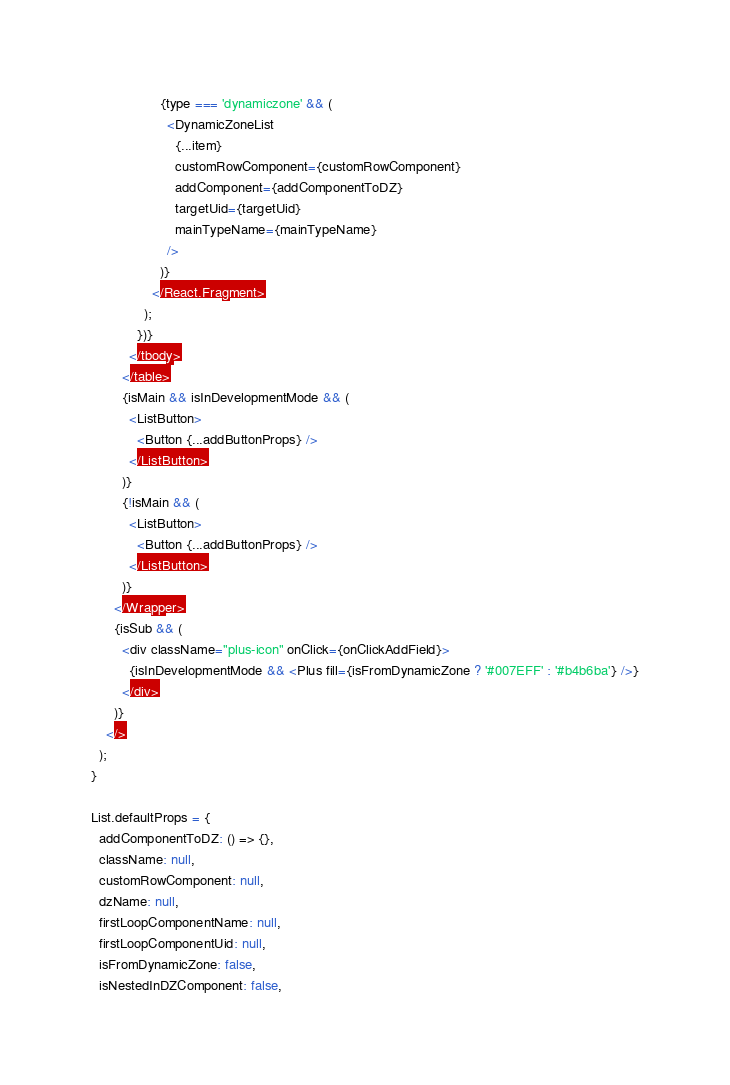<code> <loc_0><loc_0><loc_500><loc_500><_JavaScript_>
                  {type === 'dynamiczone' && (
                    <DynamicZoneList
                      {...item}
                      customRowComponent={customRowComponent}
                      addComponent={addComponentToDZ}
                      targetUid={targetUid}
                      mainTypeName={mainTypeName}
                    />
                  )}
                </React.Fragment>
              );
            })}
          </tbody>
        </table>
        {isMain && isInDevelopmentMode && (
          <ListButton>
            <Button {...addButtonProps} />
          </ListButton>
        )}
        {!isMain && (
          <ListButton>
            <Button {...addButtonProps} />
          </ListButton>
        )}
      </Wrapper>
      {isSub && (
        <div className="plus-icon" onClick={onClickAddField}>
          {isInDevelopmentMode && <Plus fill={isFromDynamicZone ? '#007EFF' : '#b4b6ba'} />}
        </div>
      )}
    </>
  );
}

List.defaultProps = {
  addComponentToDZ: () => {},
  className: null,
  customRowComponent: null,
  dzName: null,
  firstLoopComponentName: null,
  firstLoopComponentUid: null,
  isFromDynamicZone: false,
  isNestedInDZComponent: false,</code> 